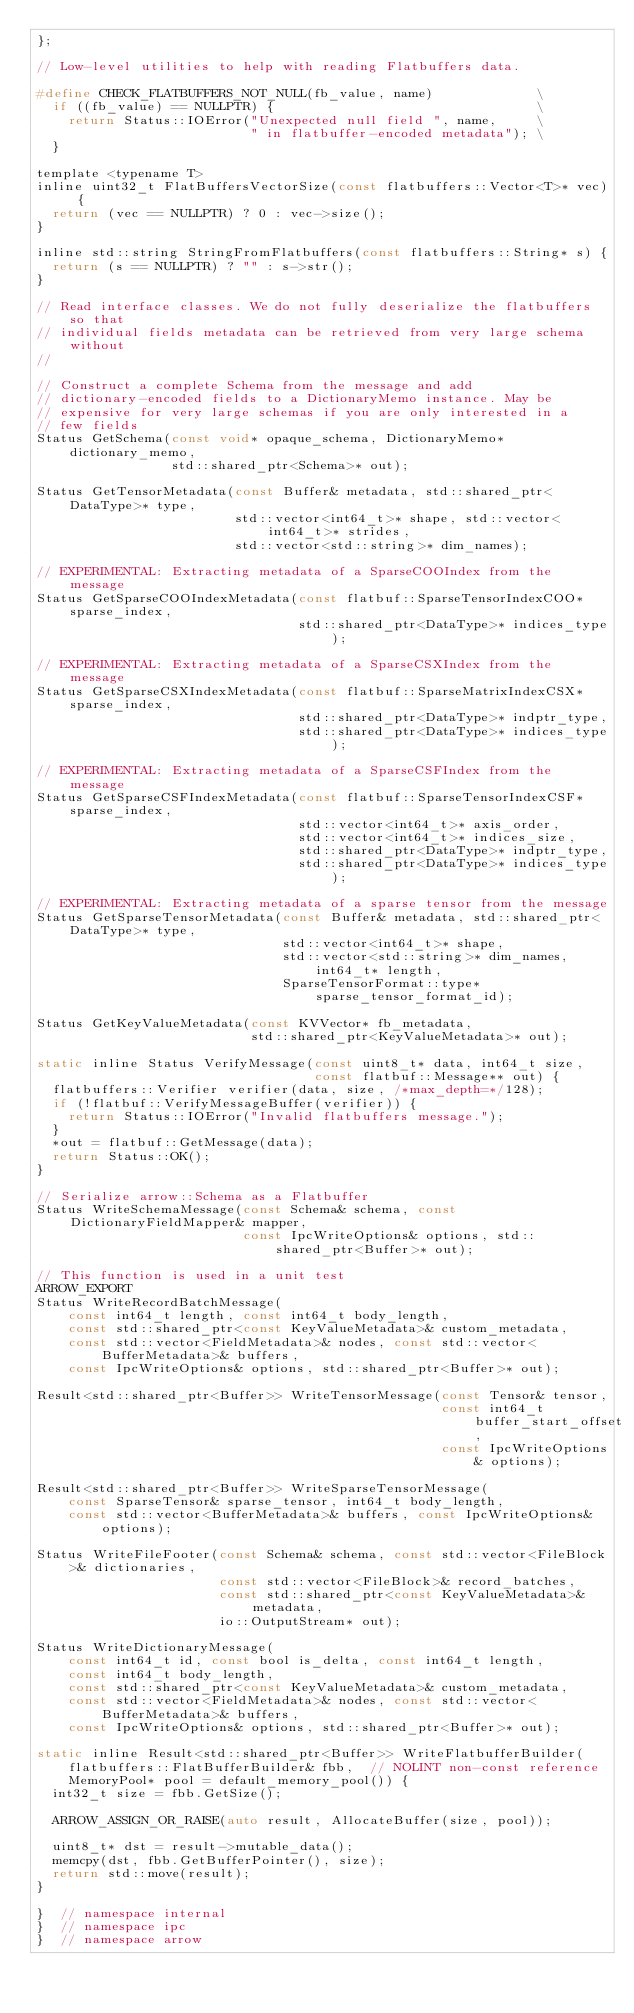Convert code to text. <code><loc_0><loc_0><loc_500><loc_500><_C_>};

// Low-level utilities to help with reading Flatbuffers data.

#define CHECK_FLATBUFFERS_NOT_NULL(fb_value, name)             \
  if ((fb_value) == NULLPTR) {                                 \
    return Status::IOError("Unexpected null field ", name,     \
                           " in flatbuffer-encoded metadata"); \
  }

template <typename T>
inline uint32_t FlatBuffersVectorSize(const flatbuffers::Vector<T>* vec) {
  return (vec == NULLPTR) ? 0 : vec->size();
}

inline std::string StringFromFlatbuffers(const flatbuffers::String* s) {
  return (s == NULLPTR) ? "" : s->str();
}

// Read interface classes. We do not fully deserialize the flatbuffers so that
// individual fields metadata can be retrieved from very large schema without
//

// Construct a complete Schema from the message and add
// dictionary-encoded fields to a DictionaryMemo instance. May be
// expensive for very large schemas if you are only interested in a
// few fields
Status GetSchema(const void* opaque_schema, DictionaryMemo* dictionary_memo,
                 std::shared_ptr<Schema>* out);

Status GetTensorMetadata(const Buffer& metadata, std::shared_ptr<DataType>* type,
                         std::vector<int64_t>* shape, std::vector<int64_t>* strides,
                         std::vector<std::string>* dim_names);

// EXPERIMENTAL: Extracting metadata of a SparseCOOIndex from the message
Status GetSparseCOOIndexMetadata(const flatbuf::SparseTensorIndexCOO* sparse_index,
                                 std::shared_ptr<DataType>* indices_type);

// EXPERIMENTAL: Extracting metadata of a SparseCSXIndex from the message
Status GetSparseCSXIndexMetadata(const flatbuf::SparseMatrixIndexCSX* sparse_index,
                                 std::shared_ptr<DataType>* indptr_type,
                                 std::shared_ptr<DataType>* indices_type);

// EXPERIMENTAL: Extracting metadata of a SparseCSFIndex from the message
Status GetSparseCSFIndexMetadata(const flatbuf::SparseTensorIndexCSF* sparse_index,
                                 std::vector<int64_t>* axis_order,
                                 std::vector<int64_t>* indices_size,
                                 std::shared_ptr<DataType>* indptr_type,
                                 std::shared_ptr<DataType>* indices_type);

// EXPERIMENTAL: Extracting metadata of a sparse tensor from the message
Status GetSparseTensorMetadata(const Buffer& metadata, std::shared_ptr<DataType>* type,
                               std::vector<int64_t>* shape,
                               std::vector<std::string>* dim_names, int64_t* length,
                               SparseTensorFormat::type* sparse_tensor_format_id);

Status GetKeyValueMetadata(const KVVector* fb_metadata,
                           std::shared_ptr<KeyValueMetadata>* out);

static inline Status VerifyMessage(const uint8_t* data, int64_t size,
                                   const flatbuf::Message** out) {
  flatbuffers::Verifier verifier(data, size, /*max_depth=*/128);
  if (!flatbuf::VerifyMessageBuffer(verifier)) {
    return Status::IOError("Invalid flatbuffers message.");
  }
  *out = flatbuf::GetMessage(data);
  return Status::OK();
}

// Serialize arrow::Schema as a Flatbuffer
Status WriteSchemaMessage(const Schema& schema, const DictionaryFieldMapper& mapper,
                          const IpcWriteOptions& options, std::shared_ptr<Buffer>* out);

// This function is used in a unit test
ARROW_EXPORT
Status WriteRecordBatchMessage(
    const int64_t length, const int64_t body_length,
    const std::shared_ptr<const KeyValueMetadata>& custom_metadata,
    const std::vector<FieldMetadata>& nodes, const std::vector<BufferMetadata>& buffers,
    const IpcWriteOptions& options, std::shared_ptr<Buffer>* out);

Result<std::shared_ptr<Buffer>> WriteTensorMessage(const Tensor& tensor,
                                                   const int64_t buffer_start_offset,
                                                   const IpcWriteOptions& options);

Result<std::shared_ptr<Buffer>> WriteSparseTensorMessage(
    const SparseTensor& sparse_tensor, int64_t body_length,
    const std::vector<BufferMetadata>& buffers, const IpcWriteOptions& options);

Status WriteFileFooter(const Schema& schema, const std::vector<FileBlock>& dictionaries,
                       const std::vector<FileBlock>& record_batches,
                       const std::shared_ptr<const KeyValueMetadata>& metadata,
                       io::OutputStream* out);

Status WriteDictionaryMessage(
    const int64_t id, const bool is_delta, const int64_t length,
    const int64_t body_length,
    const std::shared_ptr<const KeyValueMetadata>& custom_metadata,
    const std::vector<FieldMetadata>& nodes, const std::vector<BufferMetadata>& buffers,
    const IpcWriteOptions& options, std::shared_ptr<Buffer>* out);

static inline Result<std::shared_ptr<Buffer>> WriteFlatbufferBuilder(
    flatbuffers::FlatBufferBuilder& fbb,  // NOLINT non-const reference
    MemoryPool* pool = default_memory_pool()) {
  int32_t size = fbb.GetSize();

  ARROW_ASSIGN_OR_RAISE(auto result, AllocateBuffer(size, pool));

  uint8_t* dst = result->mutable_data();
  memcpy(dst, fbb.GetBufferPointer(), size);
  return std::move(result);
}

}  // namespace internal
}  // namespace ipc
}  // namespace arrow
</code> 